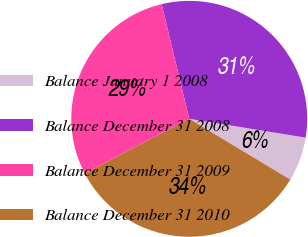Convert chart. <chart><loc_0><loc_0><loc_500><loc_500><pie_chart><fcel>Balance January 1 2008<fcel>Balance December 31 2008<fcel>Balance December 31 2009<fcel>Balance December 31 2010<nl><fcel>6.07%<fcel>31.31%<fcel>28.91%<fcel>33.71%<nl></chart> 